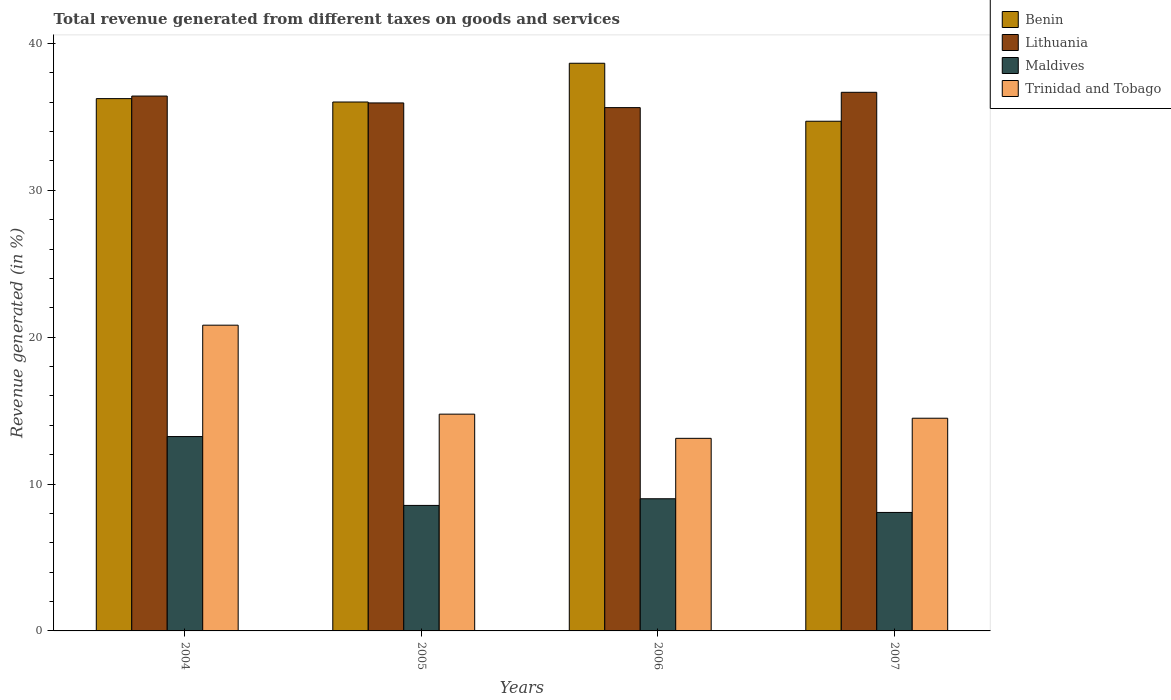How many different coloured bars are there?
Provide a short and direct response. 4. How many groups of bars are there?
Give a very brief answer. 4. How many bars are there on the 4th tick from the left?
Offer a terse response. 4. What is the label of the 1st group of bars from the left?
Offer a terse response. 2004. What is the total revenue generated in Maldives in 2005?
Keep it short and to the point. 8.55. Across all years, what is the maximum total revenue generated in Benin?
Provide a succinct answer. 38.65. Across all years, what is the minimum total revenue generated in Trinidad and Tobago?
Keep it short and to the point. 13.11. What is the total total revenue generated in Maldives in the graph?
Give a very brief answer. 38.85. What is the difference between the total revenue generated in Maldives in 2005 and that in 2007?
Provide a short and direct response. 0.48. What is the difference between the total revenue generated in Maldives in 2006 and the total revenue generated in Benin in 2004?
Offer a terse response. -27.25. What is the average total revenue generated in Lithuania per year?
Your answer should be very brief. 36.17. In the year 2005, what is the difference between the total revenue generated in Benin and total revenue generated in Lithuania?
Offer a terse response. 0.06. What is the ratio of the total revenue generated in Benin in 2004 to that in 2005?
Your response must be concise. 1.01. Is the difference between the total revenue generated in Benin in 2005 and 2007 greater than the difference between the total revenue generated in Lithuania in 2005 and 2007?
Provide a succinct answer. Yes. What is the difference between the highest and the second highest total revenue generated in Benin?
Your answer should be compact. 2.41. What is the difference between the highest and the lowest total revenue generated in Benin?
Offer a terse response. 3.95. In how many years, is the total revenue generated in Benin greater than the average total revenue generated in Benin taken over all years?
Make the answer very short. 1. What does the 1st bar from the left in 2006 represents?
Your answer should be very brief. Benin. What does the 4th bar from the right in 2007 represents?
Ensure brevity in your answer.  Benin. Is it the case that in every year, the sum of the total revenue generated in Maldives and total revenue generated in Benin is greater than the total revenue generated in Lithuania?
Offer a very short reply. Yes. Are all the bars in the graph horizontal?
Your answer should be very brief. No. How many years are there in the graph?
Provide a short and direct response. 4. Are the values on the major ticks of Y-axis written in scientific E-notation?
Provide a succinct answer. No. Does the graph contain grids?
Provide a short and direct response. No. How many legend labels are there?
Your response must be concise. 4. What is the title of the graph?
Provide a succinct answer. Total revenue generated from different taxes on goods and services. What is the label or title of the Y-axis?
Give a very brief answer. Revenue generated (in %). What is the Revenue generated (in %) of Benin in 2004?
Provide a succinct answer. 36.24. What is the Revenue generated (in %) of Lithuania in 2004?
Your answer should be compact. 36.42. What is the Revenue generated (in %) in Maldives in 2004?
Offer a terse response. 13.23. What is the Revenue generated (in %) of Trinidad and Tobago in 2004?
Your answer should be very brief. 20.82. What is the Revenue generated (in %) of Benin in 2005?
Give a very brief answer. 36.01. What is the Revenue generated (in %) of Lithuania in 2005?
Ensure brevity in your answer.  35.95. What is the Revenue generated (in %) of Maldives in 2005?
Your answer should be very brief. 8.55. What is the Revenue generated (in %) in Trinidad and Tobago in 2005?
Offer a terse response. 14.76. What is the Revenue generated (in %) of Benin in 2006?
Your answer should be very brief. 38.65. What is the Revenue generated (in %) of Lithuania in 2006?
Make the answer very short. 35.63. What is the Revenue generated (in %) in Maldives in 2006?
Your answer should be compact. 9. What is the Revenue generated (in %) in Trinidad and Tobago in 2006?
Keep it short and to the point. 13.11. What is the Revenue generated (in %) in Benin in 2007?
Ensure brevity in your answer.  34.71. What is the Revenue generated (in %) in Lithuania in 2007?
Keep it short and to the point. 36.67. What is the Revenue generated (in %) in Maldives in 2007?
Your answer should be compact. 8.07. What is the Revenue generated (in %) of Trinidad and Tobago in 2007?
Provide a short and direct response. 14.48. Across all years, what is the maximum Revenue generated (in %) of Benin?
Provide a succinct answer. 38.65. Across all years, what is the maximum Revenue generated (in %) in Lithuania?
Your answer should be compact. 36.67. Across all years, what is the maximum Revenue generated (in %) of Maldives?
Provide a succinct answer. 13.23. Across all years, what is the maximum Revenue generated (in %) of Trinidad and Tobago?
Offer a very short reply. 20.82. Across all years, what is the minimum Revenue generated (in %) of Benin?
Keep it short and to the point. 34.71. Across all years, what is the minimum Revenue generated (in %) in Lithuania?
Ensure brevity in your answer.  35.63. Across all years, what is the minimum Revenue generated (in %) in Maldives?
Offer a terse response. 8.07. Across all years, what is the minimum Revenue generated (in %) in Trinidad and Tobago?
Provide a short and direct response. 13.11. What is the total Revenue generated (in %) in Benin in the graph?
Offer a very short reply. 145.62. What is the total Revenue generated (in %) in Lithuania in the graph?
Offer a terse response. 144.68. What is the total Revenue generated (in %) of Maldives in the graph?
Offer a very short reply. 38.85. What is the total Revenue generated (in %) in Trinidad and Tobago in the graph?
Give a very brief answer. 63.17. What is the difference between the Revenue generated (in %) of Benin in 2004 and that in 2005?
Your response must be concise. 0.23. What is the difference between the Revenue generated (in %) in Lithuania in 2004 and that in 2005?
Provide a succinct answer. 0.47. What is the difference between the Revenue generated (in %) of Maldives in 2004 and that in 2005?
Give a very brief answer. 4.69. What is the difference between the Revenue generated (in %) of Trinidad and Tobago in 2004 and that in 2005?
Ensure brevity in your answer.  6.06. What is the difference between the Revenue generated (in %) of Benin in 2004 and that in 2006?
Ensure brevity in your answer.  -2.41. What is the difference between the Revenue generated (in %) of Lithuania in 2004 and that in 2006?
Your answer should be very brief. 0.79. What is the difference between the Revenue generated (in %) in Maldives in 2004 and that in 2006?
Give a very brief answer. 4.23. What is the difference between the Revenue generated (in %) of Trinidad and Tobago in 2004 and that in 2006?
Give a very brief answer. 7.71. What is the difference between the Revenue generated (in %) in Benin in 2004 and that in 2007?
Ensure brevity in your answer.  1.54. What is the difference between the Revenue generated (in %) in Lithuania in 2004 and that in 2007?
Your answer should be compact. -0.25. What is the difference between the Revenue generated (in %) in Maldives in 2004 and that in 2007?
Offer a very short reply. 5.17. What is the difference between the Revenue generated (in %) of Trinidad and Tobago in 2004 and that in 2007?
Offer a terse response. 6.34. What is the difference between the Revenue generated (in %) of Benin in 2005 and that in 2006?
Your answer should be very brief. -2.64. What is the difference between the Revenue generated (in %) of Lithuania in 2005 and that in 2006?
Offer a terse response. 0.32. What is the difference between the Revenue generated (in %) in Maldives in 2005 and that in 2006?
Give a very brief answer. -0.45. What is the difference between the Revenue generated (in %) of Trinidad and Tobago in 2005 and that in 2006?
Offer a very short reply. 1.65. What is the difference between the Revenue generated (in %) of Benin in 2005 and that in 2007?
Your answer should be very brief. 1.31. What is the difference between the Revenue generated (in %) in Lithuania in 2005 and that in 2007?
Provide a short and direct response. -0.72. What is the difference between the Revenue generated (in %) of Maldives in 2005 and that in 2007?
Offer a terse response. 0.48. What is the difference between the Revenue generated (in %) in Trinidad and Tobago in 2005 and that in 2007?
Your answer should be compact. 0.28. What is the difference between the Revenue generated (in %) of Benin in 2006 and that in 2007?
Your answer should be compact. 3.95. What is the difference between the Revenue generated (in %) of Lithuania in 2006 and that in 2007?
Give a very brief answer. -1.04. What is the difference between the Revenue generated (in %) in Maldives in 2006 and that in 2007?
Offer a very short reply. 0.93. What is the difference between the Revenue generated (in %) of Trinidad and Tobago in 2006 and that in 2007?
Your answer should be very brief. -1.37. What is the difference between the Revenue generated (in %) in Benin in 2004 and the Revenue generated (in %) in Lithuania in 2005?
Offer a terse response. 0.29. What is the difference between the Revenue generated (in %) in Benin in 2004 and the Revenue generated (in %) in Maldives in 2005?
Make the answer very short. 27.7. What is the difference between the Revenue generated (in %) of Benin in 2004 and the Revenue generated (in %) of Trinidad and Tobago in 2005?
Offer a very short reply. 21.48. What is the difference between the Revenue generated (in %) of Lithuania in 2004 and the Revenue generated (in %) of Maldives in 2005?
Your response must be concise. 27.87. What is the difference between the Revenue generated (in %) in Lithuania in 2004 and the Revenue generated (in %) in Trinidad and Tobago in 2005?
Your answer should be compact. 21.66. What is the difference between the Revenue generated (in %) in Maldives in 2004 and the Revenue generated (in %) in Trinidad and Tobago in 2005?
Offer a terse response. -1.53. What is the difference between the Revenue generated (in %) in Benin in 2004 and the Revenue generated (in %) in Lithuania in 2006?
Offer a very short reply. 0.61. What is the difference between the Revenue generated (in %) in Benin in 2004 and the Revenue generated (in %) in Maldives in 2006?
Offer a very short reply. 27.25. What is the difference between the Revenue generated (in %) in Benin in 2004 and the Revenue generated (in %) in Trinidad and Tobago in 2006?
Make the answer very short. 23.13. What is the difference between the Revenue generated (in %) in Lithuania in 2004 and the Revenue generated (in %) in Maldives in 2006?
Your answer should be compact. 27.42. What is the difference between the Revenue generated (in %) in Lithuania in 2004 and the Revenue generated (in %) in Trinidad and Tobago in 2006?
Ensure brevity in your answer.  23.31. What is the difference between the Revenue generated (in %) in Maldives in 2004 and the Revenue generated (in %) in Trinidad and Tobago in 2006?
Your answer should be compact. 0.12. What is the difference between the Revenue generated (in %) in Benin in 2004 and the Revenue generated (in %) in Lithuania in 2007?
Give a very brief answer. -0.43. What is the difference between the Revenue generated (in %) in Benin in 2004 and the Revenue generated (in %) in Maldives in 2007?
Your response must be concise. 28.18. What is the difference between the Revenue generated (in %) in Benin in 2004 and the Revenue generated (in %) in Trinidad and Tobago in 2007?
Keep it short and to the point. 21.76. What is the difference between the Revenue generated (in %) in Lithuania in 2004 and the Revenue generated (in %) in Maldives in 2007?
Provide a succinct answer. 28.35. What is the difference between the Revenue generated (in %) of Lithuania in 2004 and the Revenue generated (in %) of Trinidad and Tobago in 2007?
Keep it short and to the point. 21.94. What is the difference between the Revenue generated (in %) of Maldives in 2004 and the Revenue generated (in %) of Trinidad and Tobago in 2007?
Your response must be concise. -1.25. What is the difference between the Revenue generated (in %) in Benin in 2005 and the Revenue generated (in %) in Lithuania in 2006?
Offer a terse response. 0.38. What is the difference between the Revenue generated (in %) of Benin in 2005 and the Revenue generated (in %) of Maldives in 2006?
Offer a terse response. 27.02. What is the difference between the Revenue generated (in %) of Benin in 2005 and the Revenue generated (in %) of Trinidad and Tobago in 2006?
Provide a short and direct response. 22.9. What is the difference between the Revenue generated (in %) in Lithuania in 2005 and the Revenue generated (in %) in Maldives in 2006?
Your answer should be very brief. 26.95. What is the difference between the Revenue generated (in %) of Lithuania in 2005 and the Revenue generated (in %) of Trinidad and Tobago in 2006?
Give a very brief answer. 22.84. What is the difference between the Revenue generated (in %) in Maldives in 2005 and the Revenue generated (in %) in Trinidad and Tobago in 2006?
Offer a very short reply. -4.57. What is the difference between the Revenue generated (in %) of Benin in 2005 and the Revenue generated (in %) of Lithuania in 2007?
Give a very brief answer. -0.66. What is the difference between the Revenue generated (in %) in Benin in 2005 and the Revenue generated (in %) in Maldives in 2007?
Your answer should be compact. 27.95. What is the difference between the Revenue generated (in %) in Benin in 2005 and the Revenue generated (in %) in Trinidad and Tobago in 2007?
Provide a succinct answer. 21.53. What is the difference between the Revenue generated (in %) of Lithuania in 2005 and the Revenue generated (in %) of Maldives in 2007?
Offer a very short reply. 27.89. What is the difference between the Revenue generated (in %) in Lithuania in 2005 and the Revenue generated (in %) in Trinidad and Tobago in 2007?
Give a very brief answer. 21.47. What is the difference between the Revenue generated (in %) in Maldives in 2005 and the Revenue generated (in %) in Trinidad and Tobago in 2007?
Keep it short and to the point. -5.94. What is the difference between the Revenue generated (in %) in Benin in 2006 and the Revenue generated (in %) in Lithuania in 2007?
Give a very brief answer. 1.98. What is the difference between the Revenue generated (in %) in Benin in 2006 and the Revenue generated (in %) in Maldives in 2007?
Keep it short and to the point. 30.59. What is the difference between the Revenue generated (in %) of Benin in 2006 and the Revenue generated (in %) of Trinidad and Tobago in 2007?
Provide a short and direct response. 24.17. What is the difference between the Revenue generated (in %) in Lithuania in 2006 and the Revenue generated (in %) in Maldives in 2007?
Offer a very short reply. 27.57. What is the difference between the Revenue generated (in %) of Lithuania in 2006 and the Revenue generated (in %) of Trinidad and Tobago in 2007?
Your answer should be compact. 21.15. What is the difference between the Revenue generated (in %) of Maldives in 2006 and the Revenue generated (in %) of Trinidad and Tobago in 2007?
Keep it short and to the point. -5.48. What is the average Revenue generated (in %) in Benin per year?
Offer a terse response. 36.4. What is the average Revenue generated (in %) in Lithuania per year?
Your answer should be very brief. 36.17. What is the average Revenue generated (in %) of Maldives per year?
Offer a terse response. 9.71. What is the average Revenue generated (in %) in Trinidad and Tobago per year?
Give a very brief answer. 15.79. In the year 2004, what is the difference between the Revenue generated (in %) of Benin and Revenue generated (in %) of Lithuania?
Keep it short and to the point. -0.17. In the year 2004, what is the difference between the Revenue generated (in %) of Benin and Revenue generated (in %) of Maldives?
Ensure brevity in your answer.  23.01. In the year 2004, what is the difference between the Revenue generated (in %) in Benin and Revenue generated (in %) in Trinidad and Tobago?
Provide a succinct answer. 15.43. In the year 2004, what is the difference between the Revenue generated (in %) of Lithuania and Revenue generated (in %) of Maldives?
Provide a succinct answer. 23.19. In the year 2004, what is the difference between the Revenue generated (in %) of Lithuania and Revenue generated (in %) of Trinidad and Tobago?
Give a very brief answer. 15.6. In the year 2004, what is the difference between the Revenue generated (in %) in Maldives and Revenue generated (in %) in Trinidad and Tobago?
Ensure brevity in your answer.  -7.58. In the year 2005, what is the difference between the Revenue generated (in %) of Benin and Revenue generated (in %) of Lithuania?
Your answer should be very brief. 0.06. In the year 2005, what is the difference between the Revenue generated (in %) in Benin and Revenue generated (in %) in Maldives?
Keep it short and to the point. 27.47. In the year 2005, what is the difference between the Revenue generated (in %) of Benin and Revenue generated (in %) of Trinidad and Tobago?
Offer a terse response. 21.25. In the year 2005, what is the difference between the Revenue generated (in %) in Lithuania and Revenue generated (in %) in Maldives?
Provide a succinct answer. 27.41. In the year 2005, what is the difference between the Revenue generated (in %) in Lithuania and Revenue generated (in %) in Trinidad and Tobago?
Ensure brevity in your answer.  21.19. In the year 2005, what is the difference between the Revenue generated (in %) in Maldives and Revenue generated (in %) in Trinidad and Tobago?
Offer a very short reply. -6.22. In the year 2006, what is the difference between the Revenue generated (in %) in Benin and Revenue generated (in %) in Lithuania?
Your answer should be very brief. 3.02. In the year 2006, what is the difference between the Revenue generated (in %) of Benin and Revenue generated (in %) of Maldives?
Your answer should be compact. 29.65. In the year 2006, what is the difference between the Revenue generated (in %) of Benin and Revenue generated (in %) of Trinidad and Tobago?
Your response must be concise. 25.54. In the year 2006, what is the difference between the Revenue generated (in %) in Lithuania and Revenue generated (in %) in Maldives?
Your answer should be compact. 26.63. In the year 2006, what is the difference between the Revenue generated (in %) of Lithuania and Revenue generated (in %) of Trinidad and Tobago?
Offer a very short reply. 22.52. In the year 2006, what is the difference between the Revenue generated (in %) of Maldives and Revenue generated (in %) of Trinidad and Tobago?
Give a very brief answer. -4.11. In the year 2007, what is the difference between the Revenue generated (in %) in Benin and Revenue generated (in %) in Lithuania?
Provide a short and direct response. -1.97. In the year 2007, what is the difference between the Revenue generated (in %) in Benin and Revenue generated (in %) in Maldives?
Make the answer very short. 26.64. In the year 2007, what is the difference between the Revenue generated (in %) of Benin and Revenue generated (in %) of Trinidad and Tobago?
Provide a short and direct response. 20.22. In the year 2007, what is the difference between the Revenue generated (in %) in Lithuania and Revenue generated (in %) in Maldives?
Your answer should be very brief. 28.61. In the year 2007, what is the difference between the Revenue generated (in %) in Lithuania and Revenue generated (in %) in Trinidad and Tobago?
Your answer should be very brief. 22.19. In the year 2007, what is the difference between the Revenue generated (in %) of Maldives and Revenue generated (in %) of Trinidad and Tobago?
Your answer should be very brief. -6.42. What is the ratio of the Revenue generated (in %) of Benin in 2004 to that in 2005?
Your response must be concise. 1.01. What is the ratio of the Revenue generated (in %) in Maldives in 2004 to that in 2005?
Your answer should be very brief. 1.55. What is the ratio of the Revenue generated (in %) in Trinidad and Tobago in 2004 to that in 2005?
Keep it short and to the point. 1.41. What is the ratio of the Revenue generated (in %) of Benin in 2004 to that in 2006?
Your response must be concise. 0.94. What is the ratio of the Revenue generated (in %) of Lithuania in 2004 to that in 2006?
Ensure brevity in your answer.  1.02. What is the ratio of the Revenue generated (in %) of Maldives in 2004 to that in 2006?
Keep it short and to the point. 1.47. What is the ratio of the Revenue generated (in %) of Trinidad and Tobago in 2004 to that in 2006?
Offer a terse response. 1.59. What is the ratio of the Revenue generated (in %) in Benin in 2004 to that in 2007?
Provide a short and direct response. 1.04. What is the ratio of the Revenue generated (in %) in Maldives in 2004 to that in 2007?
Give a very brief answer. 1.64. What is the ratio of the Revenue generated (in %) of Trinidad and Tobago in 2004 to that in 2007?
Your response must be concise. 1.44. What is the ratio of the Revenue generated (in %) of Benin in 2005 to that in 2006?
Give a very brief answer. 0.93. What is the ratio of the Revenue generated (in %) in Maldives in 2005 to that in 2006?
Offer a very short reply. 0.95. What is the ratio of the Revenue generated (in %) in Trinidad and Tobago in 2005 to that in 2006?
Provide a short and direct response. 1.13. What is the ratio of the Revenue generated (in %) in Benin in 2005 to that in 2007?
Offer a terse response. 1.04. What is the ratio of the Revenue generated (in %) in Lithuania in 2005 to that in 2007?
Ensure brevity in your answer.  0.98. What is the ratio of the Revenue generated (in %) of Maldives in 2005 to that in 2007?
Keep it short and to the point. 1.06. What is the ratio of the Revenue generated (in %) of Trinidad and Tobago in 2005 to that in 2007?
Offer a terse response. 1.02. What is the ratio of the Revenue generated (in %) of Benin in 2006 to that in 2007?
Make the answer very short. 1.11. What is the ratio of the Revenue generated (in %) of Lithuania in 2006 to that in 2007?
Your answer should be very brief. 0.97. What is the ratio of the Revenue generated (in %) of Maldives in 2006 to that in 2007?
Your answer should be compact. 1.12. What is the ratio of the Revenue generated (in %) of Trinidad and Tobago in 2006 to that in 2007?
Offer a terse response. 0.91. What is the difference between the highest and the second highest Revenue generated (in %) in Benin?
Offer a very short reply. 2.41. What is the difference between the highest and the second highest Revenue generated (in %) in Lithuania?
Offer a terse response. 0.25. What is the difference between the highest and the second highest Revenue generated (in %) in Maldives?
Keep it short and to the point. 4.23. What is the difference between the highest and the second highest Revenue generated (in %) of Trinidad and Tobago?
Offer a terse response. 6.06. What is the difference between the highest and the lowest Revenue generated (in %) of Benin?
Give a very brief answer. 3.95. What is the difference between the highest and the lowest Revenue generated (in %) of Lithuania?
Give a very brief answer. 1.04. What is the difference between the highest and the lowest Revenue generated (in %) of Maldives?
Your answer should be very brief. 5.17. What is the difference between the highest and the lowest Revenue generated (in %) of Trinidad and Tobago?
Give a very brief answer. 7.71. 